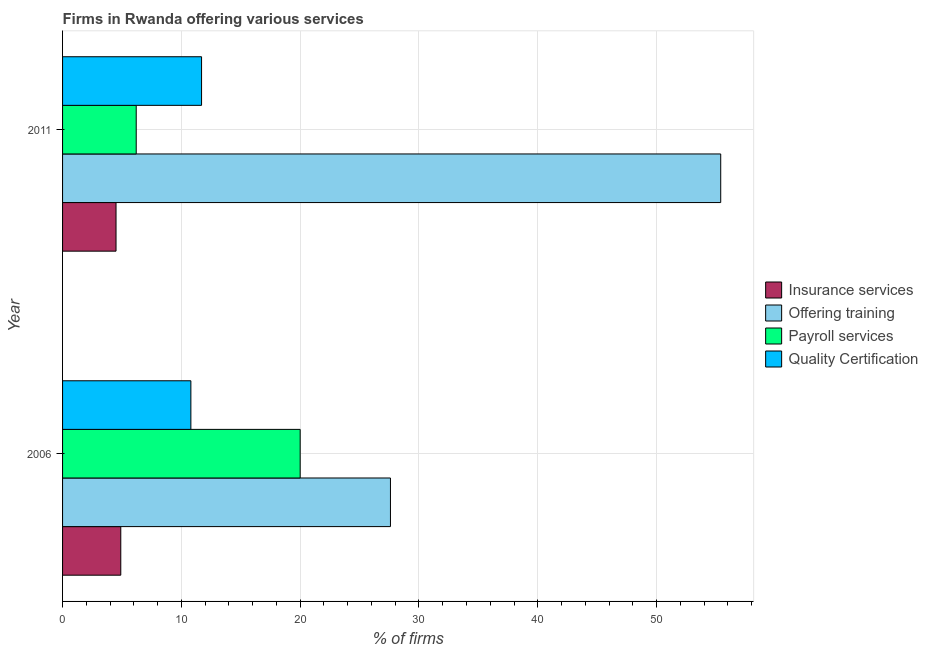How many different coloured bars are there?
Ensure brevity in your answer.  4. How many groups of bars are there?
Your response must be concise. 2. Are the number of bars per tick equal to the number of legend labels?
Your answer should be very brief. Yes. Are the number of bars on each tick of the Y-axis equal?
Ensure brevity in your answer.  Yes. How many bars are there on the 2nd tick from the bottom?
Provide a succinct answer. 4. What is the percentage of firms offering quality certification in 2006?
Offer a very short reply. 10.8. In which year was the percentage of firms offering payroll services minimum?
Make the answer very short. 2011. What is the difference between the percentage of firms offering training in 2006 and that in 2011?
Make the answer very short. -27.8. What is the difference between the percentage of firms offering payroll services in 2011 and the percentage of firms offering insurance services in 2006?
Your answer should be compact. 1.3. What is the average percentage of firms offering payroll services per year?
Provide a succinct answer. 13.1. In the year 2006, what is the difference between the percentage of firms offering training and percentage of firms offering insurance services?
Offer a terse response. 22.7. In how many years, is the percentage of firms offering insurance services greater than 56 %?
Offer a terse response. 0. What is the ratio of the percentage of firms offering training in 2006 to that in 2011?
Provide a succinct answer. 0.5. Is the percentage of firms offering training in 2006 less than that in 2011?
Provide a succinct answer. Yes. Is the difference between the percentage of firms offering payroll services in 2006 and 2011 greater than the difference between the percentage of firms offering insurance services in 2006 and 2011?
Provide a short and direct response. Yes. Is it the case that in every year, the sum of the percentage of firms offering insurance services and percentage of firms offering quality certification is greater than the sum of percentage of firms offering training and percentage of firms offering payroll services?
Give a very brief answer. Yes. What does the 4th bar from the top in 2006 represents?
Offer a terse response. Insurance services. What does the 3rd bar from the bottom in 2006 represents?
Give a very brief answer. Payroll services. Is it the case that in every year, the sum of the percentage of firms offering insurance services and percentage of firms offering training is greater than the percentage of firms offering payroll services?
Give a very brief answer. Yes. How many bars are there?
Offer a terse response. 8. Are all the bars in the graph horizontal?
Keep it short and to the point. Yes. What is the difference between two consecutive major ticks on the X-axis?
Your answer should be very brief. 10. Does the graph contain any zero values?
Your response must be concise. No. How many legend labels are there?
Your answer should be compact. 4. How are the legend labels stacked?
Your answer should be compact. Vertical. What is the title of the graph?
Offer a terse response. Firms in Rwanda offering various services . Does "International Development Association" appear as one of the legend labels in the graph?
Offer a very short reply. No. What is the label or title of the X-axis?
Ensure brevity in your answer.  % of firms. What is the label or title of the Y-axis?
Your answer should be compact. Year. What is the % of firms of Insurance services in 2006?
Provide a short and direct response. 4.9. What is the % of firms of Offering training in 2006?
Your response must be concise. 27.6. What is the % of firms in Payroll services in 2006?
Give a very brief answer. 20. What is the % of firms in Insurance services in 2011?
Offer a terse response. 4.5. What is the % of firms of Offering training in 2011?
Your response must be concise. 55.4. What is the % of firms in Quality Certification in 2011?
Make the answer very short. 11.7. Across all years, what is the maximum % of firms in Insurance services?
Offer a very short reply. 4.9. Across all years, what is the maximum % of firms of Offering training?
Ensure brevity in your answer.  55.4. Across all years, what is the maximum % of firms of Quality Certification?
Your response must be concise. 11.7. Across all years, what is the minimum % of firms of Offering training?
Offer a terse response. 27.6. Across all years, what is the minimum % of firms in Payroll services?
Ensure brevity in your answer.  6.2. Across all years, what is the minimum % of firms in Quality Certification?
Keep it short and to the point. 10.8. What is the total % of firms in Payroll services in the graph?
Offer a terse response. 26.2. What is the difference between the % of firms in Offering training in 2006 and that in 2011?
Provide a short and direct response. -27.8. What is the difference between the % of firms in Insurance services in 2006 and the % of firms in Offering training in 2011?
Make the answer very short. -50.5. What is the difference between the % of firms in Insurance services in 2006 and the % of firms in Payroll services in 2011?
Provide a succinct answer. -1.3. What is the difference between the % of firms of Offering training in 2006 and the % of firms of Payroll services in 2011?
Offer a terse response. 21.4. What is the difference between the % of firms of Payroll services in 2006 and the % of firms of Quality Certification in 2011?
Give a very brief answer. 8.3. What is the average % of firms in Insurance services per year?
Keep it short and to the point. 4.7. What is the average % of firms in Offering training per year?
Provide a short and direct response. 41.5. What is the average % of firms of Payroll services per year?
Provide a succinct answer. 13.1. What is the average % of firms of Quality Certification per year?
Keep it short and to the point. 11.25. In the year 2006, what is the difference between the % of firms in Insurance services and % of firms in Offering training?
Keep it short and to the point. -22.7. In the year 2006, what is the difference between the % of firms of Insurance services and % of firms of Payroll services?
Offer a very short reply. -15.1. In the year 2011, what is the difference between the % of firms in Insurance services and % of firms in Offering training?
Your answer should be very brief. -50.9. In the year 2011, what is the difference between the % of firms in Insurance services and % of firms in Quality Certification?
Give a very brief answer. -7.2. In the year 2011, what is the difference between the % of firms in Offering training and % of firms in Payroll services?
Make the answer very short. 49.2. In the year 2011, what is the difference between the % of firms of Offering training and % of firms of Quality Certification?
Offer a very short reply. 43.7. What is the ratio of the % of firms in Insurance services in 2006 to that in 2011?
Keep it short and to the point. 1.09. What is the ratio of the % of firms in Offering training in 2006 to that in 2011?
Offer a very short reply. 0.5. What is the ratio of the % of firms in Payroll services in 2006 to that in 2011?
Keep it short and to the point. 3.23. What is the ratio of the % of firms in Quality Certification in 2006 to that in 2011?
Your answer should be compact. 0.92. What is the difference between the highest and the second highest % of firms of Offering training?
Ensure brevity in your answer.  27.8. What is the difference between the highest and the lowest % of firms of Insurance services?
Make the answer very short. 0.4. What is the difference between the highest and the lowest % of firms in Offering training?
Offer a terse response. 27.8. What is the difference between the highest and the lowest % of firms in Quality Certification?
Ensure brevity in your answer.  0.9. 